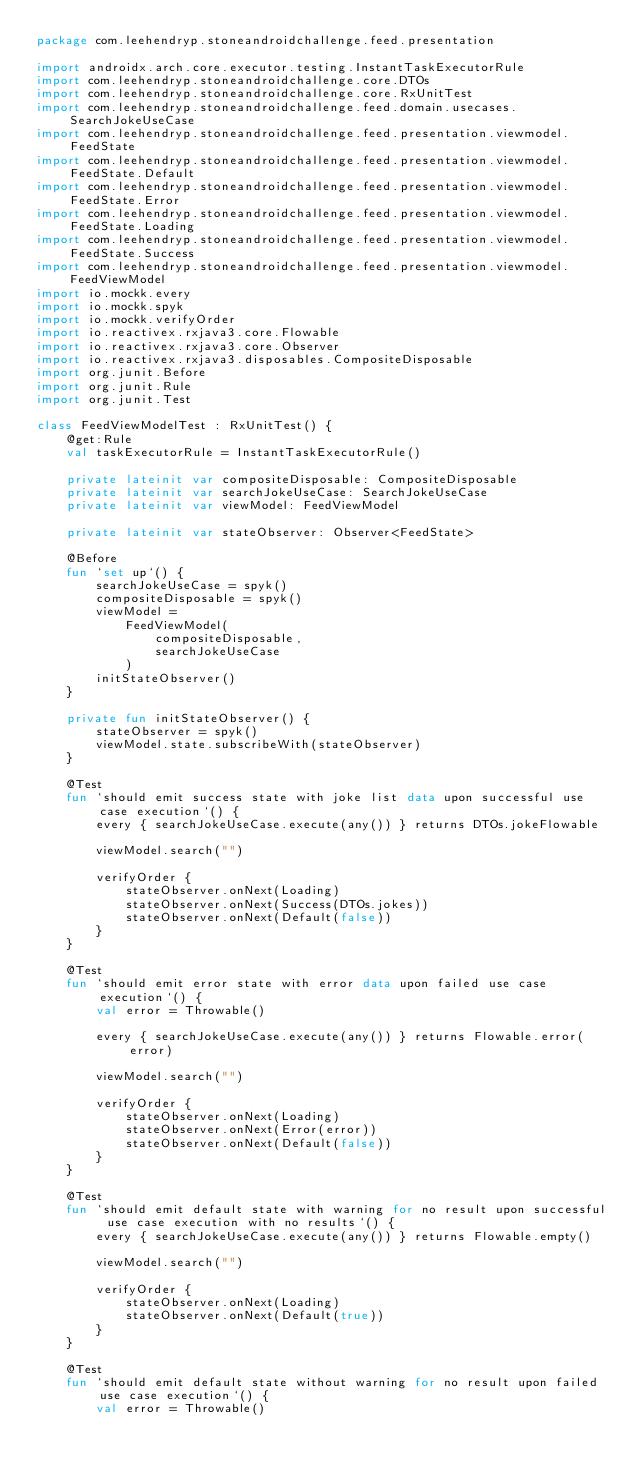Convert code to text. <code><loc_0><loc_0><loc_500><loc_500><_Kotlin_>package com.leehendryp.stoneandroidchallenge.feed.presentation

import androidx.arch.core.executor.testing.InstantTaskExecutorRule
import com.leehendryp.stoneandroidchallenge.core.DTOs
import com.leehendryp.stoneandroidchallenge.core.RxUnitTest
import com.leehendryp.stoneandroidchallenge.feed.domain.usecases.SearchJokeUseCase
import com.leehendryp.stoneandroidchallenge.feed.presentation.viewmodel.FeedState
import com.leehendryp.stoneandroidchallenge.feed.presentation.viewmodel.FeedState.Default
import com.leehendryp.stoneandroidchallenge.feed.presentation.viewmodel.FeedState.Error
import com.leehendryp.stoneandroidchallenge.feed.presentation.viewmodel.FeedState.Loading
import com.leehendryp.stoneandroidchallenge.feed.presentation.viewmodel.FeedState.Success
import com.leehendryp.stoneandroidchallenge.feed.presentation.viewmodel.FeedViewModel
import io.mockk.every
import io.mockk.spyk
import io.mockk.verifyOrder
import io.reactivex.rxjava3.core.Flowable
import io.reactivex.rxjava3.core.Observer
import io.reactivex.rxjava3.disposables.CompositeDisposable
import org.junit.Before
import org.junit.Rule
import org.junit.Test

class FeedViewModelTest : RxUnitTest() {
    @get:Rule
    val taskExecutorRule = InstantTaskExecutorRule()

    private lateinit var compositeDisposable: CompositeDisposable
    private lateinit var searchJokeUseCase: SearchJokeUseCase
    private lateinit var viewModel: FeedViewModel

    private lateinit var stateObserver: Observer<FeedState>

    @Before
    fun `set up`() {
        searchJokeUseCase = spyk()
        compositeDisposable = spyk()
        viewModel =
            FeedViewModel(
                compositeDisposable,
                searchJokeUseCase
            )
        initStateObserver()
    }

    private fun initStateObserver() {
        stateObserver = spyk()
        viewModel.state.subscribeWith(stateObserver)
    }

    @Test
    fun `should emit success state with joke list data upon successful use case execution`() {
        every { searchJokeUseCase.execute(any()) } returns DTOs.jokeFlowable

        viewModel.search("")

        verifyOrder {
            stateObserver.onNext(Loading)
            stateObserver.onNext(Success(DTOs.jokes))
            stateObserver.onNext(Default(false))
        }
    }

    @Test
    fun `should emit error state with error data upon failed use case execution`() {
        val error = Throwable()

        every { searchJokeUseCase.execute(any()) } returns Flowable.error(error)

        viewModel.search("")

        verifyOrder {
            stateObserver.onNext(Loading)
            stateObserver.onNext(Error(error))
            stateObserver.onNext(Default(false))
        }
    }

    @Test
    fun `should emit default state with warning for no result upon successful use case execution with no results`() {
        every { searchJokeUseCase.execute(any()) } returns Flowable.empty()

        viewModel.search("")

        verifyOrder {
            stateObserver.onNext(Loading)
            stateObserver.onNext(Default(true))
        }
    }

    @Test
    fun `should emit default state without warning for no result upon failed use case execution`() {
        val error = Throwable()
</code> 